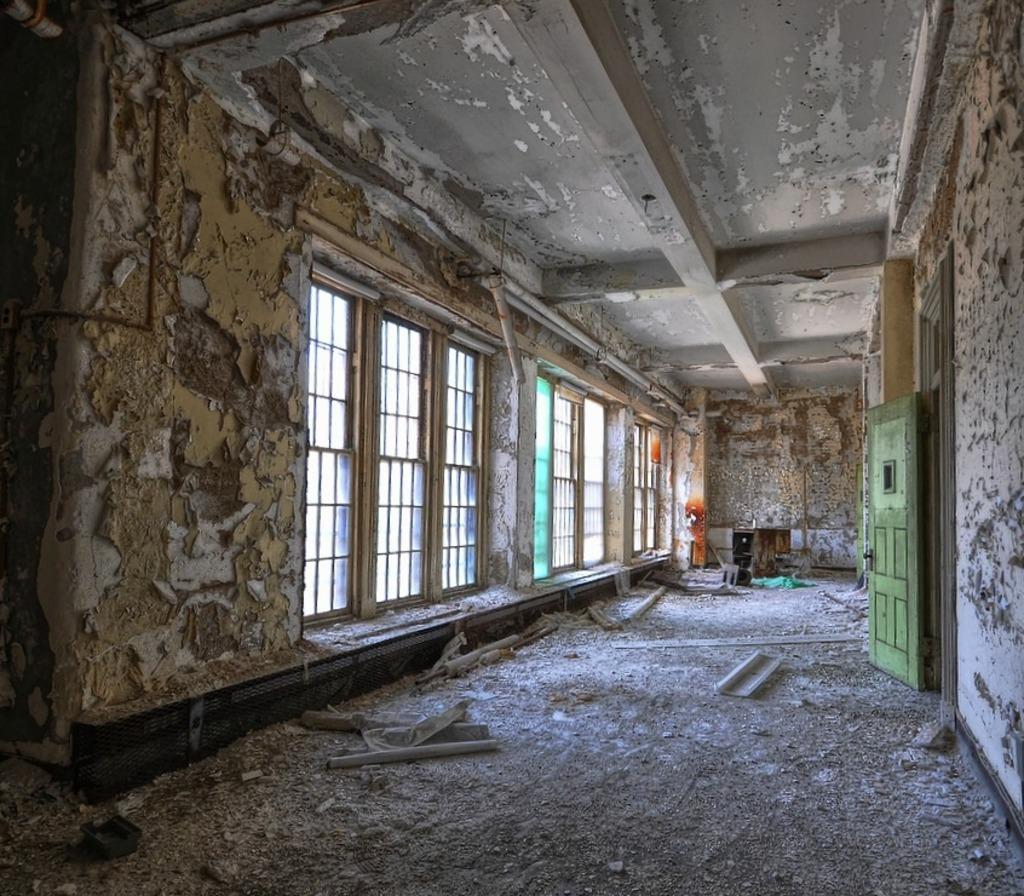In one or two sentences, can you explain what this image depicts? This is a picture of an old building. In the background there are windows and wall. On the right there is a door. On the floor there is debris. At the top it is ceiling. 